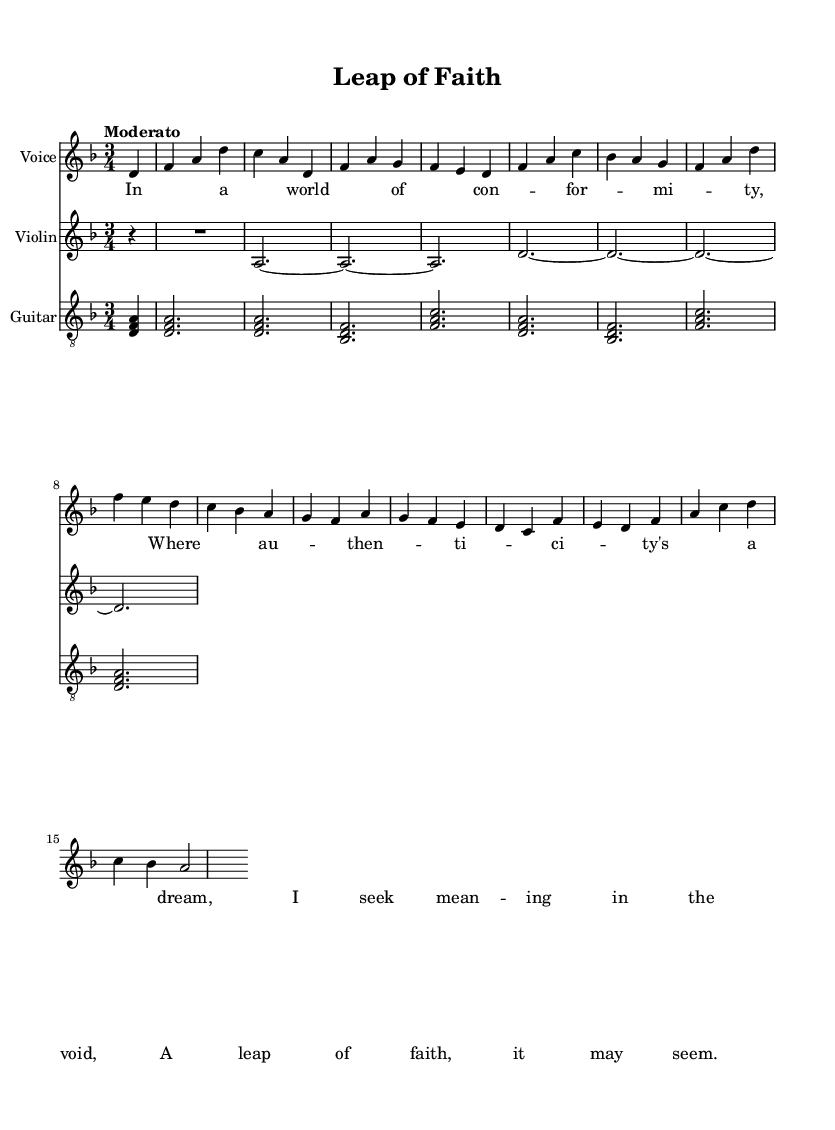What is the key signature of this music? The key signature is indicated at the beginning of the staff. In this case, it shows one flat, which corresponds to the key of D minor.
Answer: D minor What is the time signature of this music? The time signature, found next to the key signature at the beginning of the sheet, indicates how many beats are in a measure. Here, the time signature is 3/4, meaning there are three beats per measure.
Answer: 3/4 What is the tempo marking for this song? The tempo marking is mentioned in Italian and usually indicates the speed of the piece. It reads "Moderato," which generally denotes a moderate pace.
Answer: Moderato How many measures are there in the voice part? By counting the measures indicated by vertical lines in the vocal section, there are a total of ten measures present.
Answer: 10 What instrumental accompaniment is used alongside the voice? The sheet specifies additional staves indicating other instruments. Here, both violin and guitar are written to accompany the voice part.
Answer: Violin and Guitar Which line do the lyrics correspond to in the vocal part? The lyrics are aligned underneath the notes in the vocal part, showing which syllables correspond to specific musical notes, meaning they match directly with the melody of the voice lines.
Answer: Voice part 